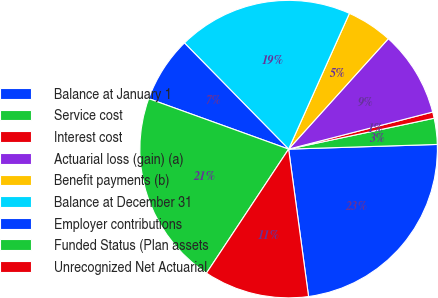Convert chart. <chart><loc_0><loc_0><loc_500><loc_500><pie_chart><fcel>Balance at January 1<fcel>Service cost<fcel>Interest cost<fcel>Actuarial loss (gain) (a)<fcel>Benefit payments (b)<fcel>Balance at December 31<fcel>Employer contributions<fcel>Funded Status (Plan assets<fcel>Unrecognized Net Actuarial<nl><fcel>23.36%<fcel>2.83%<fcel>0.68%<fcel>9.3%<fcel>4.99%<fcel>19.05%<fcel>7.14%<fcel>21.2%<fcel>11.45%<nl></chart> 